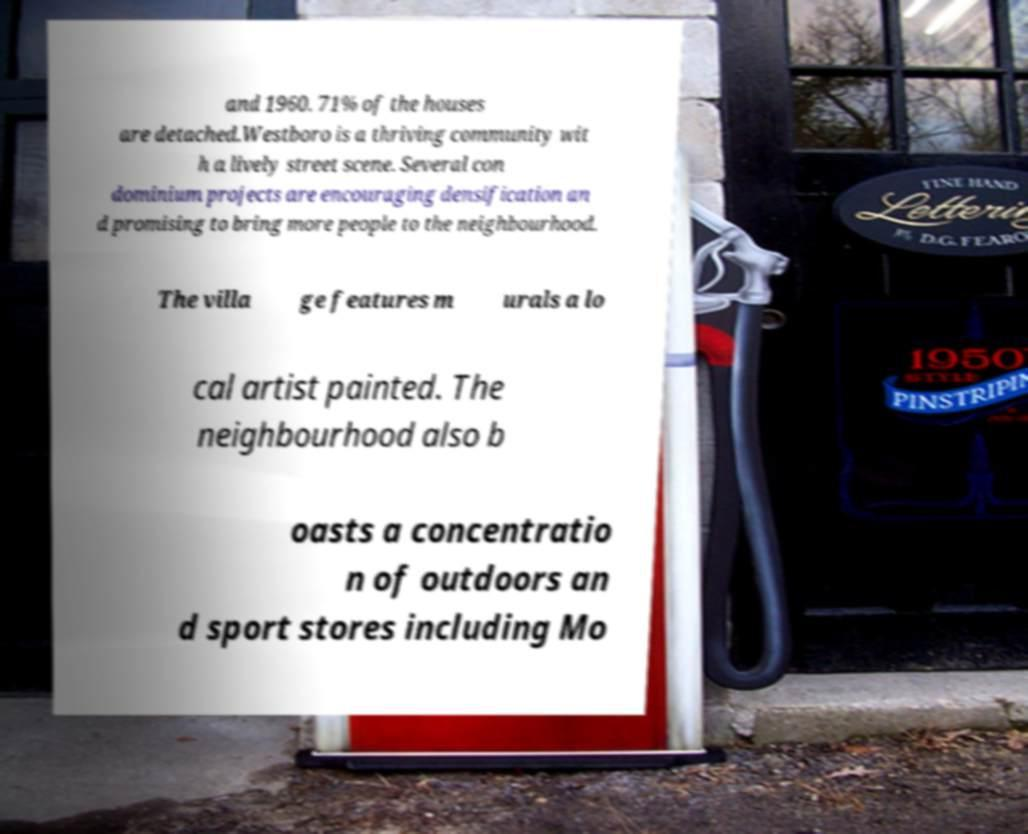What messages or text are displayed in this image? I need them in a readable, typed format. and 1960. 71% of the houses are detached.Westboro is a thriving community wit h a lively street scene. Several con dominium projects are encouraging densification an d promising to bring more people to the neighbourhood. The villa ge features m urals a lo cal artist painted. The neighbourhood also b oasts a concentratio n of outdoors an d sport stores including Mo 